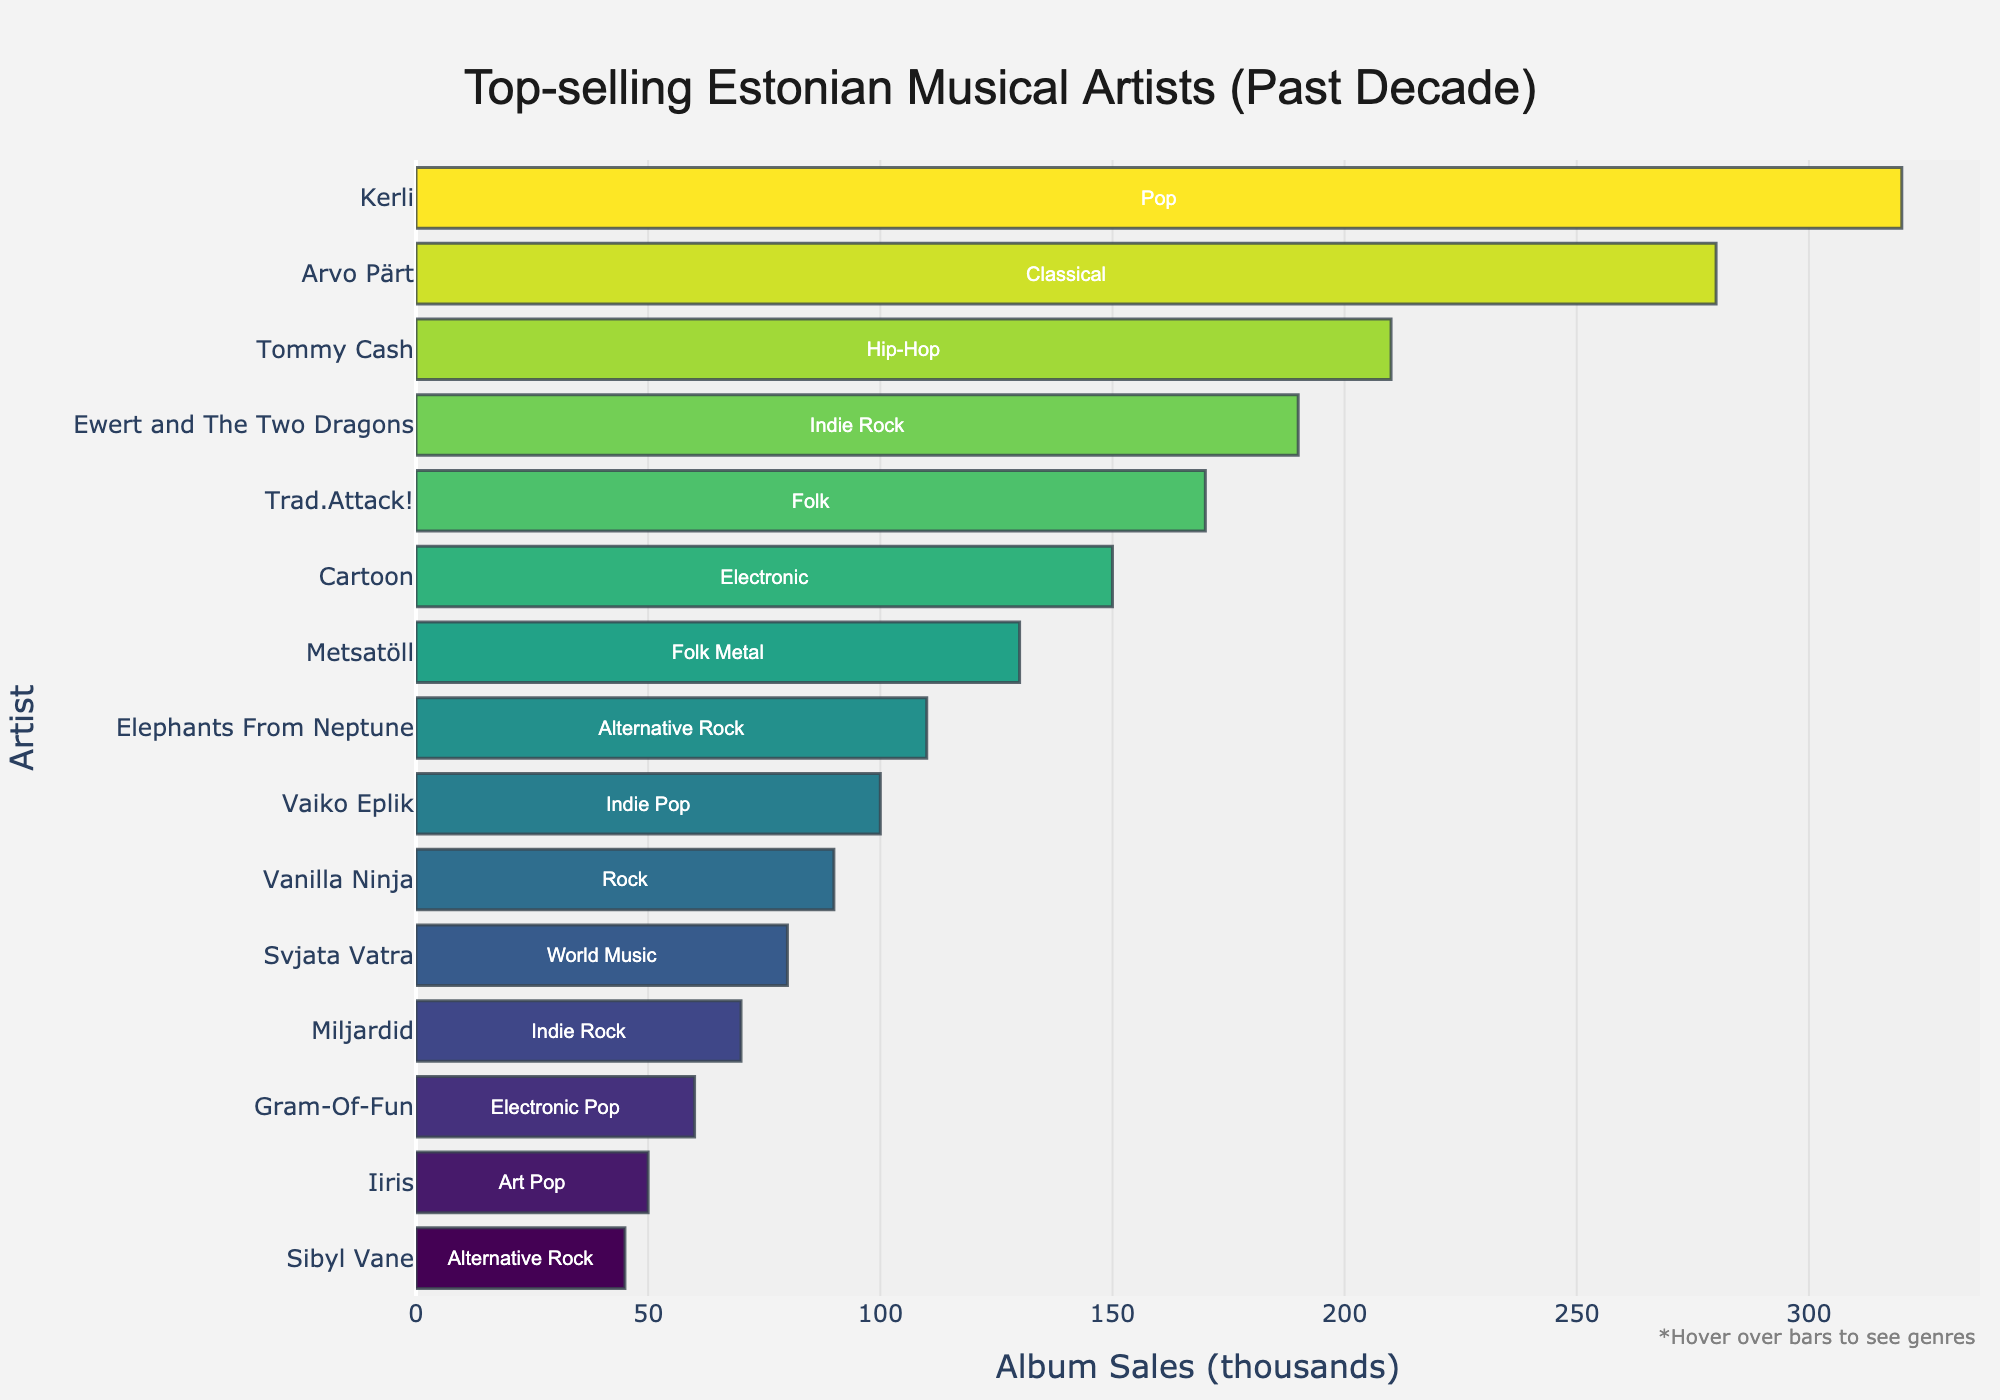Which artist has the highest album sales? The artist with the highest album sales is the one whose bar is the longest on the x-axis. The longest bar corresponds to Kerli.
Answer: Kerli Which genre does Ewert and The Two Dragons perform in? Ewert and The Two Dragons' genre can be found by looking at the label beside their bar. It is 'Indie Rock'.
Answer: Indie Rock How do the album sales of Classical compare to Hip-Hop? The album sales of Classical correspond to Arvo Pärt with 280, and Hip-Hop corresponds to Tommy Cash with 210. 280 is greater than 210.
Answer: Classical has higher sales What's the combined album sales of the top two artists? The top two artists are Kerli and Arvo Pärt, with album sales of 320 and 280 respectively. 320 + 280 = 600.
Answer: 600 What is the average album sales of the top 3 selling artists? The top 3 selling artists are Kerli (320), Arvo Pärt (280), and Tommy Cash (210). Their total sales is 320 + 280 + 210 = 810. The average is 810 / 3 = 270.
Answer: 270 Which genre has the lowest album sales, and who is the artist? The artist with the lowest album sales is at the bottom of the chart with the shortest bar. This corresponds to Sibyl Vane in the Alternative Rock genre with 45 sales.
Answer: Alternative Rock, Sibyl Vane Are there more artists in the Rock genres (including sub-genres like Indie Rock, Alternative Rock, etc.) than in the Electronic genres? There are multiple Rock genres: Ewert and The Two Dragons (Indie Rock), Vanilla Ninja (Rock), Elephants From Neptune (Alternative Rock), Miljardid (Indie Rock), and Sibyl Vane (Alternative Rock)—5 artists. For Electronic genres: Cartoon (Electronic) and Gram-Of-Fun (Electronic Pop)—2 artists.
Answer: Yes What is the difference in album sales between the highest selling Folk artist and the highest selling Indie Rock artist? The highest selling Folk artist is Trad.Attack! with 170 sales, and the highest selling Indie Rock artist is Ewert and The Two Dragons with 190 sales. The difference is 190 - 170 = 20.
Answer: 20 Which artist in the Pop genre has the highest album sales? By looking at the genre label next to each bar, for Pop, the artist with the highest album sales is Kerli.
Answer: Kerli 